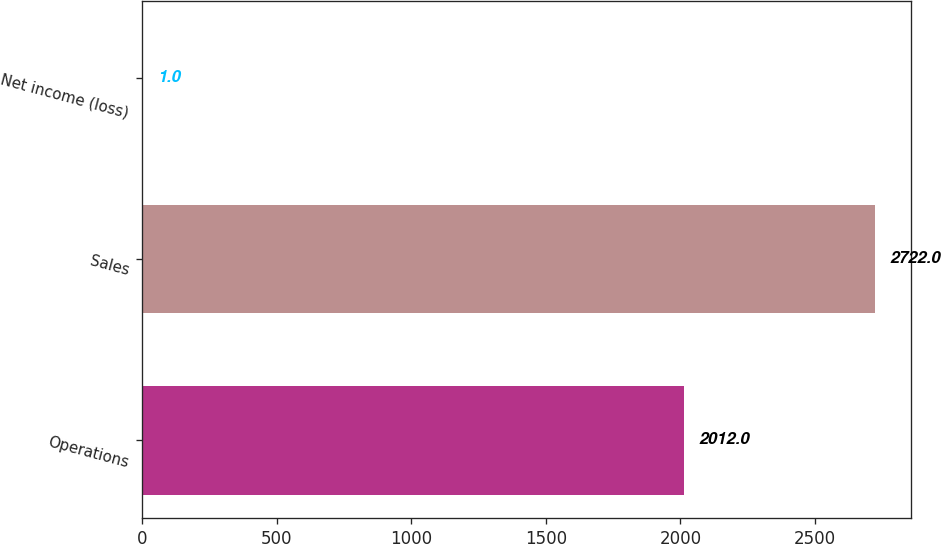Convert chart to OTSL. <chart><loc_0><loc_0><loc_500><loc_500><bar_chart><fcel>Operations<fcel>Sales<fcel>Net income (loss)<nl><fcel>2012<fcel>2722<fcel>1<nl></chart> 